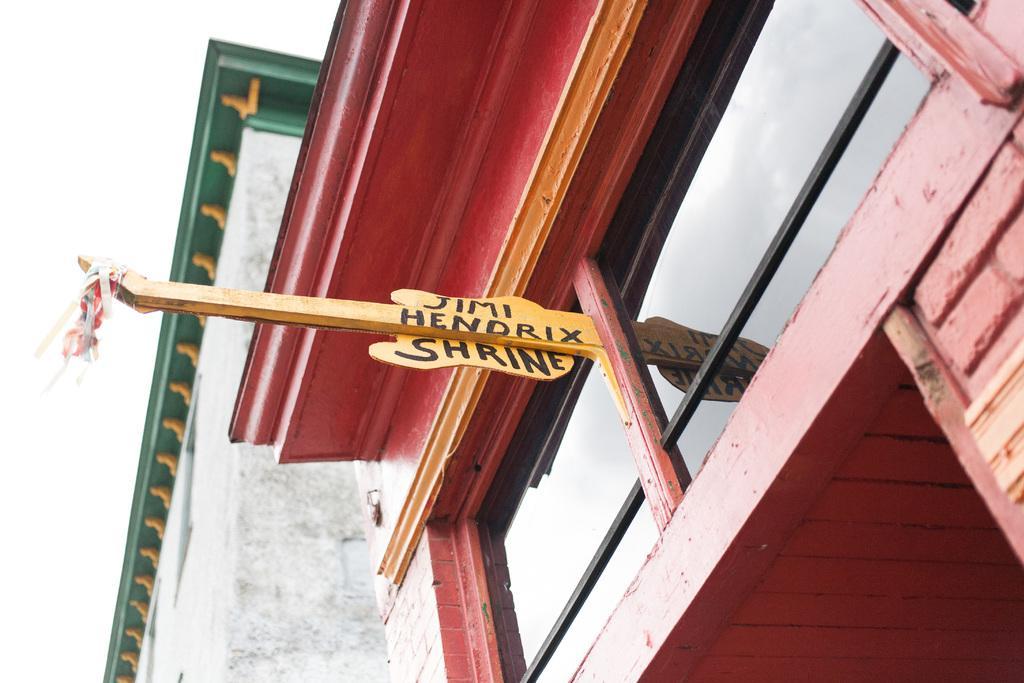Please provide a concise description of this image. This picture seems to be clicked outside. In the center we can see the text on a wooden object which is attached to the window and we can see the metal rods and the building and some other objects. The background of the image is white in color. 